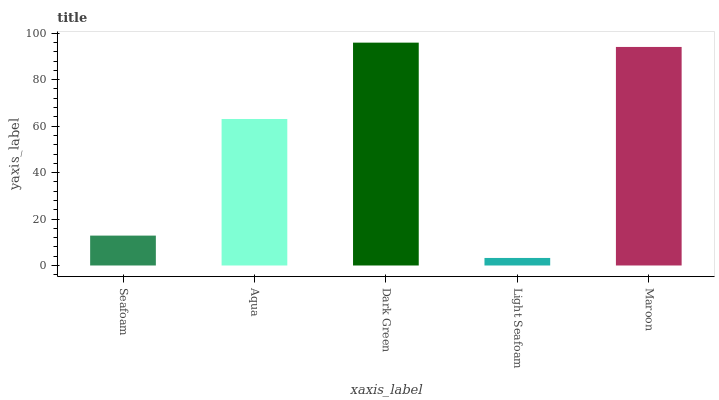Is Light Seafoam the minimum?
Answer yes or no. Yes. Is Dark Green the maximum?
Answer yes or no. Yes. Is Aqua the minimum?
Answer yes or no. No. Is Aqua the maximum?
Answer yes or no. No. Is Aqua greater than Seafoam?
Answer yes or no. Yes. Is Seafoam less than Aqua?
Answer yes or no. Yes. Is Seafoam greater than Aqua?
Answer yes or no. No. Is Aqua less than Seafoam?
Answer yes or no. No. Is Aqua the high median?
Answer yes or no. Yes. Is Aqua the low median?
Answer yes or no. Yes. Is Dark Green the high median?
Answer yes or no. No. Is Light Seafoam the low median?
Answer yes or no. No. 